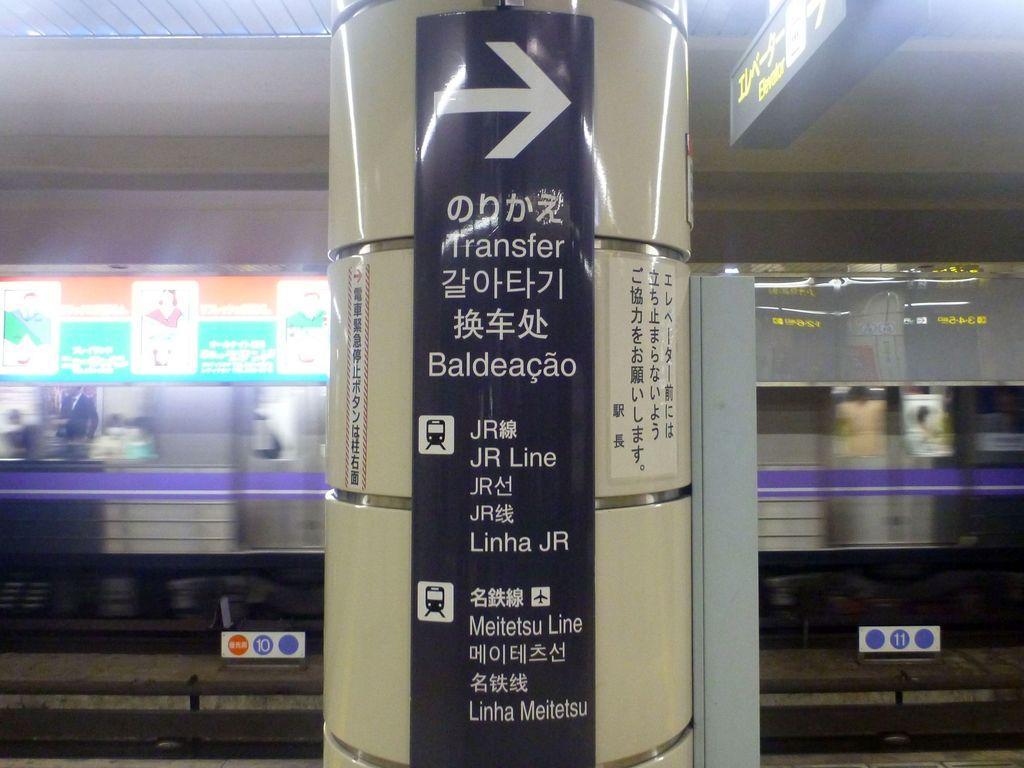<image>
Write a terse but informative summary of the picture. Pole in a subway that tells you where to transfer. 